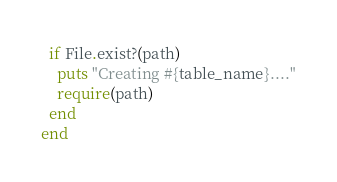Convert code to text. <code><loc_0><loc_0><loc_500><loc_500><_Ruby_>  if File.exist?(path)
    puts "Creating #{table_name}...."
    require(path)
  end
end</code> 